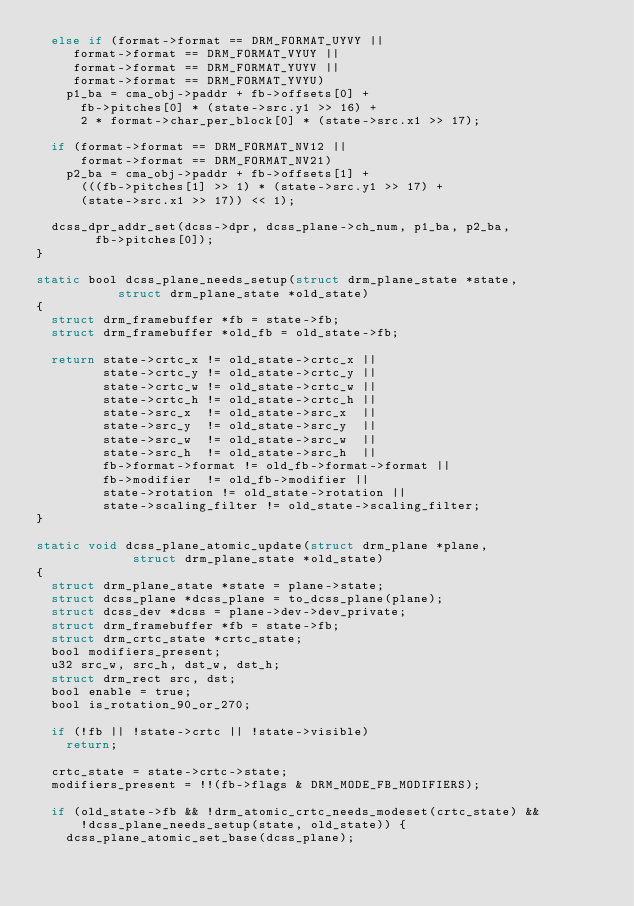Convert code to text. <code><loc_0><loc_0><loc_500><loc_500><_C_>	else if (format->format == DRM_FORMAT_UYVY ||
		 format->format == DRM_FORMAT_VYUY ||
		 format->format == DRM_FORMAT_YUYV ||
		 format->format == DRM_FORMAT_YVYU)
		p1_ba = cma_obj->paddr + fb->offsets[0] +
			fb->pitches[0] * (state->src.y1 >> 16) +
			2 * format->char_per_block[0] * (state->src.x1 >> 17);

	if (format->format == DRM_FORMAT_NV12 ||
	    format->format == DRM_FORMAT_NV21)
		p2_ba = cma_obj->paddr + fb->offsets[1] +
			(((fb->pitches[1] >> 1) * (state->src.y1 >> 17) +
			(state->src.x1 >> 17)) << 1);

	dcss_dpr_addr_set(dcss->dpr, dcss_plane->ch_num, p1_ba, p2_ba,
			  fb->pitches[0]);
}

static bool dcss_plane_needs_setup(struct drm_plane_state *state,
				   struct drm_plane_state *old_state)
{
	struct drm_framebuffer *fb = state->fb;
	struct drm_framebuffer *old_fb = old_state->fb;

	return state->crtc_x != old_state->crtc_x ||
	       state->crtc_y != old_state->crtc_y ||
	       state->crtc_w != old_state->crtc_w ||
	       state->crtc_h != old_state->crtc_h ||
	       state->src_x  != old_state->src_x  ||
	       state->src_y  != old_state->src_y  ||
	       state->src_w  != old_state->src_w  ||
	       state->src_h  != old_state->src_h  ||
	       fb->format->format != old_fb->format->format ||
	       fb->modifier  != old_fb->modifier ||
	       state->rotation != old_state->rotation ||
	       state->scaling_filter != old_state->scaling_filter;
}

static void dcss_plane_atomic_update(struct drm_plane *plane,
				     struct drm_plane_state *old_state)
{
	struct drm_plane_state *state = plane->state;
	struct dcss_plane *dcss_plane = to_dcss_plane(plane);
	struct dcss_dev *dcss = plane->dev->dev_private;
	struct drm_framebuffer *fb = state->fb;
	struct drm_crtc_state *crtc_state;
	bool modifiers_present;
	u32 src_w, src_h, dst_w, dst_h;
	struct drm_rect src, dst;
	bool enable = true;
	bool is_rotation_90_or_270;

	if (!fb || !state->crtc || !state->visible)
		return;

	crtc_state = state->crtc->state;
	modifiers_present = !!(fb->flags & DRM_MODE_FB_MODIFIERS);

	if (old_state->fb && !drm_atomic_crtc_needs_modeset(crtc_state) &&
	    !dcss_plane_needs_setup(state, old_state)) {
		dcss_plane_atomic_set_base(dcss_plane);</code> 